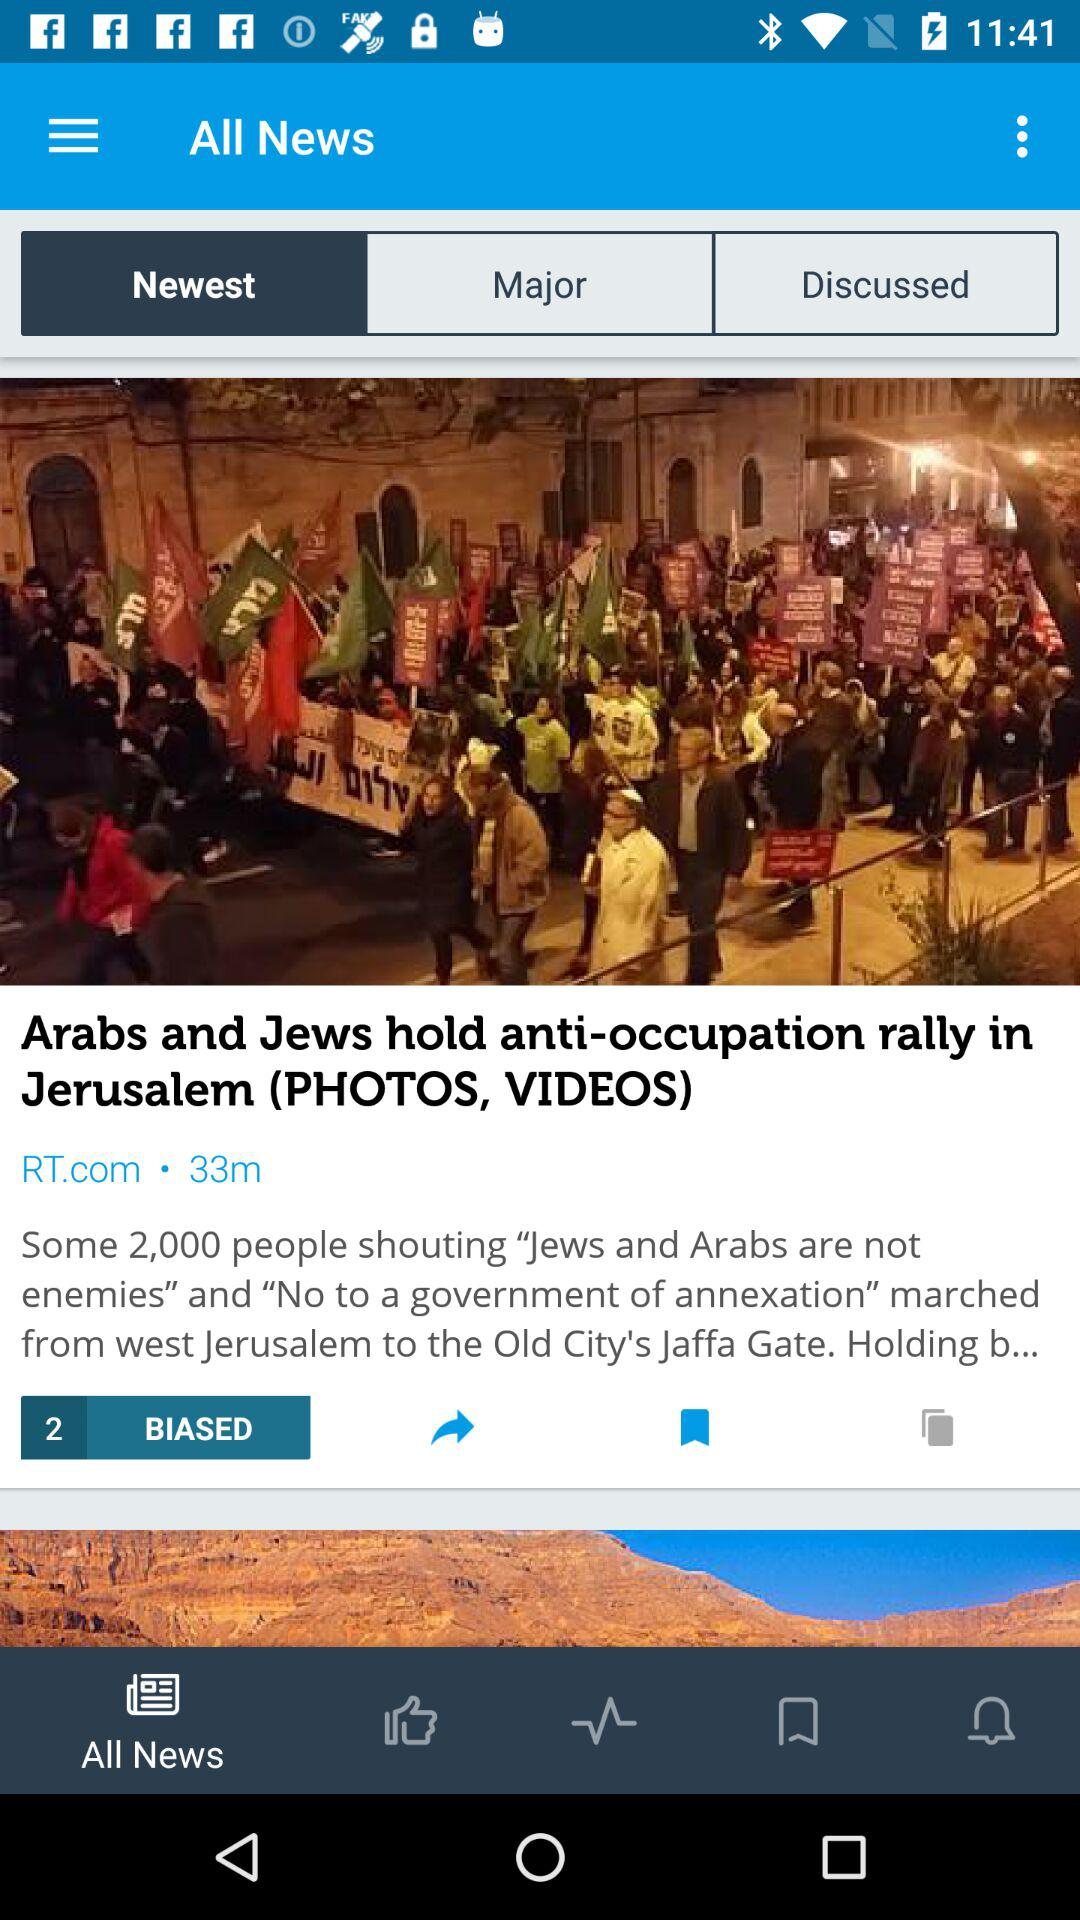What is the name of the publisher? The name of the publisher is RT.com. 